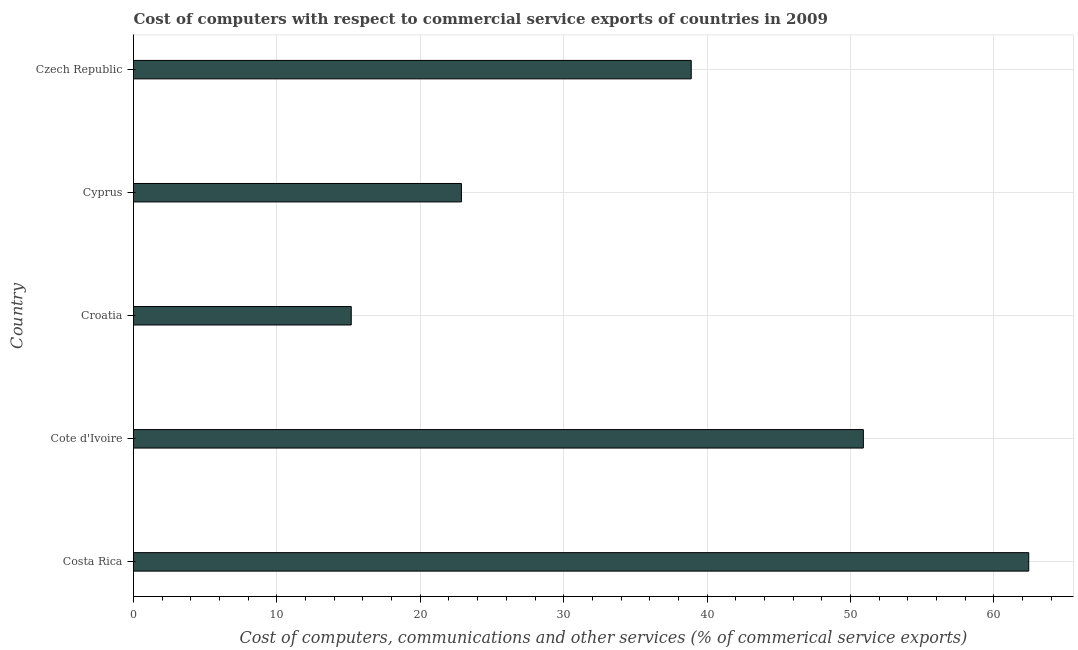Does the graph contain any zero values?
Make the answer very short. No. Does the graph contain grids?
Keep it short and to the point. Yes. What is the title of the graph?
Provide a succinct answer. Cost of computers with respect to commercial service exports of countries in 2009. What is the label or title of the X-axis?
Keep it short and to the point. Cost of computers, communications and other services (% of commerical service exports). What is the label or title of the Y-axis?
Your answer should be very brief. Country. What is the cost of communications in Cote d'Ivoire?
Make the answer very short. 50.9. Across all countries, what is the maximum  computer and other services?
Your response must be concise. 62.43. Across all countries, what is the minimum  computer and other services?
Your response must be concise. 15.18. In which country was the  computer and other services minimum?
Give a very brief answer. Croatia. What is the sum of the cost of communications?
Keep it short and to the point. 190.28. What is the difference between the  computer and other services in Cote d'Ivoire and Cyprus?
Provide a short and direct response. 28.03. What is the average cost of communications per country?
Give a very brief answer. 38.05. What is the median cost of communications?
Offer a very short reply. 38.89. In how many countries, is the cost of communications greater than 6 %?
Offer a terse response. 5. What is the ratio of the cost of communications in Cote d'Ivoire to that in Croatia?
Ensure brevity in your answer.  3.35. Is the  computer and other services in Cyprus less than that in Czech Republic?
Give a very brief answer. Yes. Is the difference between the  computer and other services in Cyprus and Czech Republic greater than the difference between any two countries?
Make the answer very short. No. What is the difference between the highest and the second highest cost of communications?
Ensure brevity in your answer.  11.53. What is the difference between the highest and the lowest cost of communications?
Make the answer very short. 47.25. How many bars are there?
Offer a terse response. 5. Are all the bars in the graph horizontal?
Give a very brief answer. Yes. How many countries are there in the graph?
Your answer should be very brief. 5. What is the difference between two consecutive major ticks on the X-axis?
Offer a terse response. 10. What is the Cost of computers, communications and other services (% of commerical service exports) of Costa Rica?
Keep it short and to the point. 62.43. What is the Cost of computers, communications and other services (% of commerical service exports) in Cote d'Ivoire?
Ensure brevity in your answer.  50.9. What is the Cost of computers, communications and other services (% of commerical service exports) in Croatia?
Provide a short and direct response. 15.18. What is the Cost of computers, communications and other services (% of commerical service exports) of Cyprus?
Offer a very short reply. 22.87. What is the Cost of computers, communications and other services (% of commerical service exports) in Czech Republic?
Your answer should be compact. 38.89. What is the difference between the Cost of computers, communications and other services (% of commerical service exports) in Costa Rica and Cote d'Ivoire?
Your answer should be compact. 11.53. What is the difference between the Cost of computers, communications and other services (% of commerical service exports) in Costa Rica and Croatia?
Your response must be concise. 47.25. What is the difference between the Cost of computers, communications and other services (% of commerical service exports) in Costa Rica and Cyprus?
Your answer should be compact. 39.56. What is the difference between the Cost of computers, communications and other services (% of commerical service exports) in Costa Rica and Czech Republic?
Your response must be concise. 23.54. What is the difference between the Cost of computers, communications and other services (% of commerical service exports) in Cote d'Ivoire and Croatia?
Give a very brief answer. 35.71. What is the difference between the Cost of computers, communications and other services (% of commerical service exports) in Cote d'Ivoire and Cyprus?
Keep it short and to the point. 28.03. What is the difference between the Cost of computers, communications and other services (% of commerical service exports) in Cote d'Ivoire and Czech Republic?
Make the answer very short. 12. What is the difference between the Cost of computers, communications and other services (% of commerical service exports) in Croatia and Cyprus?
Provide a short and direct response. -7.68. What is the difference between the Cost of computers, communications and other services (% of commerical service exports) in Croatia and Czech Republic?
Provide a succinct answer. -23.71. What is the difference between the Cost of computers, communications and other services (% of commerical service exports) in Cyprus and Czech Republic?
Give a very brief answer. -16.03. What is the ratio of the Cost of computers, communications and other services (% of commerical service exports) in Costa Rica to that in Cote d'Ivoire?
Give a very brief answer. 1.23. What is the ratio of the Cost of computers, communications and other services (% of commerical service exports) in Costa Rica to that in Croatia?
Provide a succinct answer. 4.11. What is the ratio of the Cost of computers, communications and other services (% of commerical service exports) in Costa Rica to that in Cyprus?
Your answer should be compact. 2.73. What is the ratio of the Cost of computers, communications and other services (% of commerical service exports) in Costa Rica to that in Czech Republic?
Ensure brevity in your answer.  1.6. What is the ratio of the Cost of computers, communications and other services (% of commerical service exports) in Cote d'Ivoire to that in Croatia?
Ensure brevity in your answer.  3.35. What is the ratio of the Cost of computers, communications and other services (% of commerical service exports) in Cote d'Ivoire to that in Cyprus?
Your answer should be very brief. 2.23. What is the ratio of the Cost of computers, communications and other services (% of commerical service exports) in Cote d'Ivoire to that in Czech Republic?
Your answer should be compact. 1.31. What is the ratio of the Cost of computers, communications and other services (% of commerical service exports) in Croatia to that in Cyprus?
Keep it short and to the point. 0.66. What is the ratio of the Cost of computers, communications and other services (% of commerical service exports) in Croatia to that in Czech Republic?
Your response must be concise. 0.39. What is the ratio of the Cost of computers, communications and other services (% of commerical service exports) in Cyprus to that in Czech Republic?
Keep it short and to the point. 0.59. 